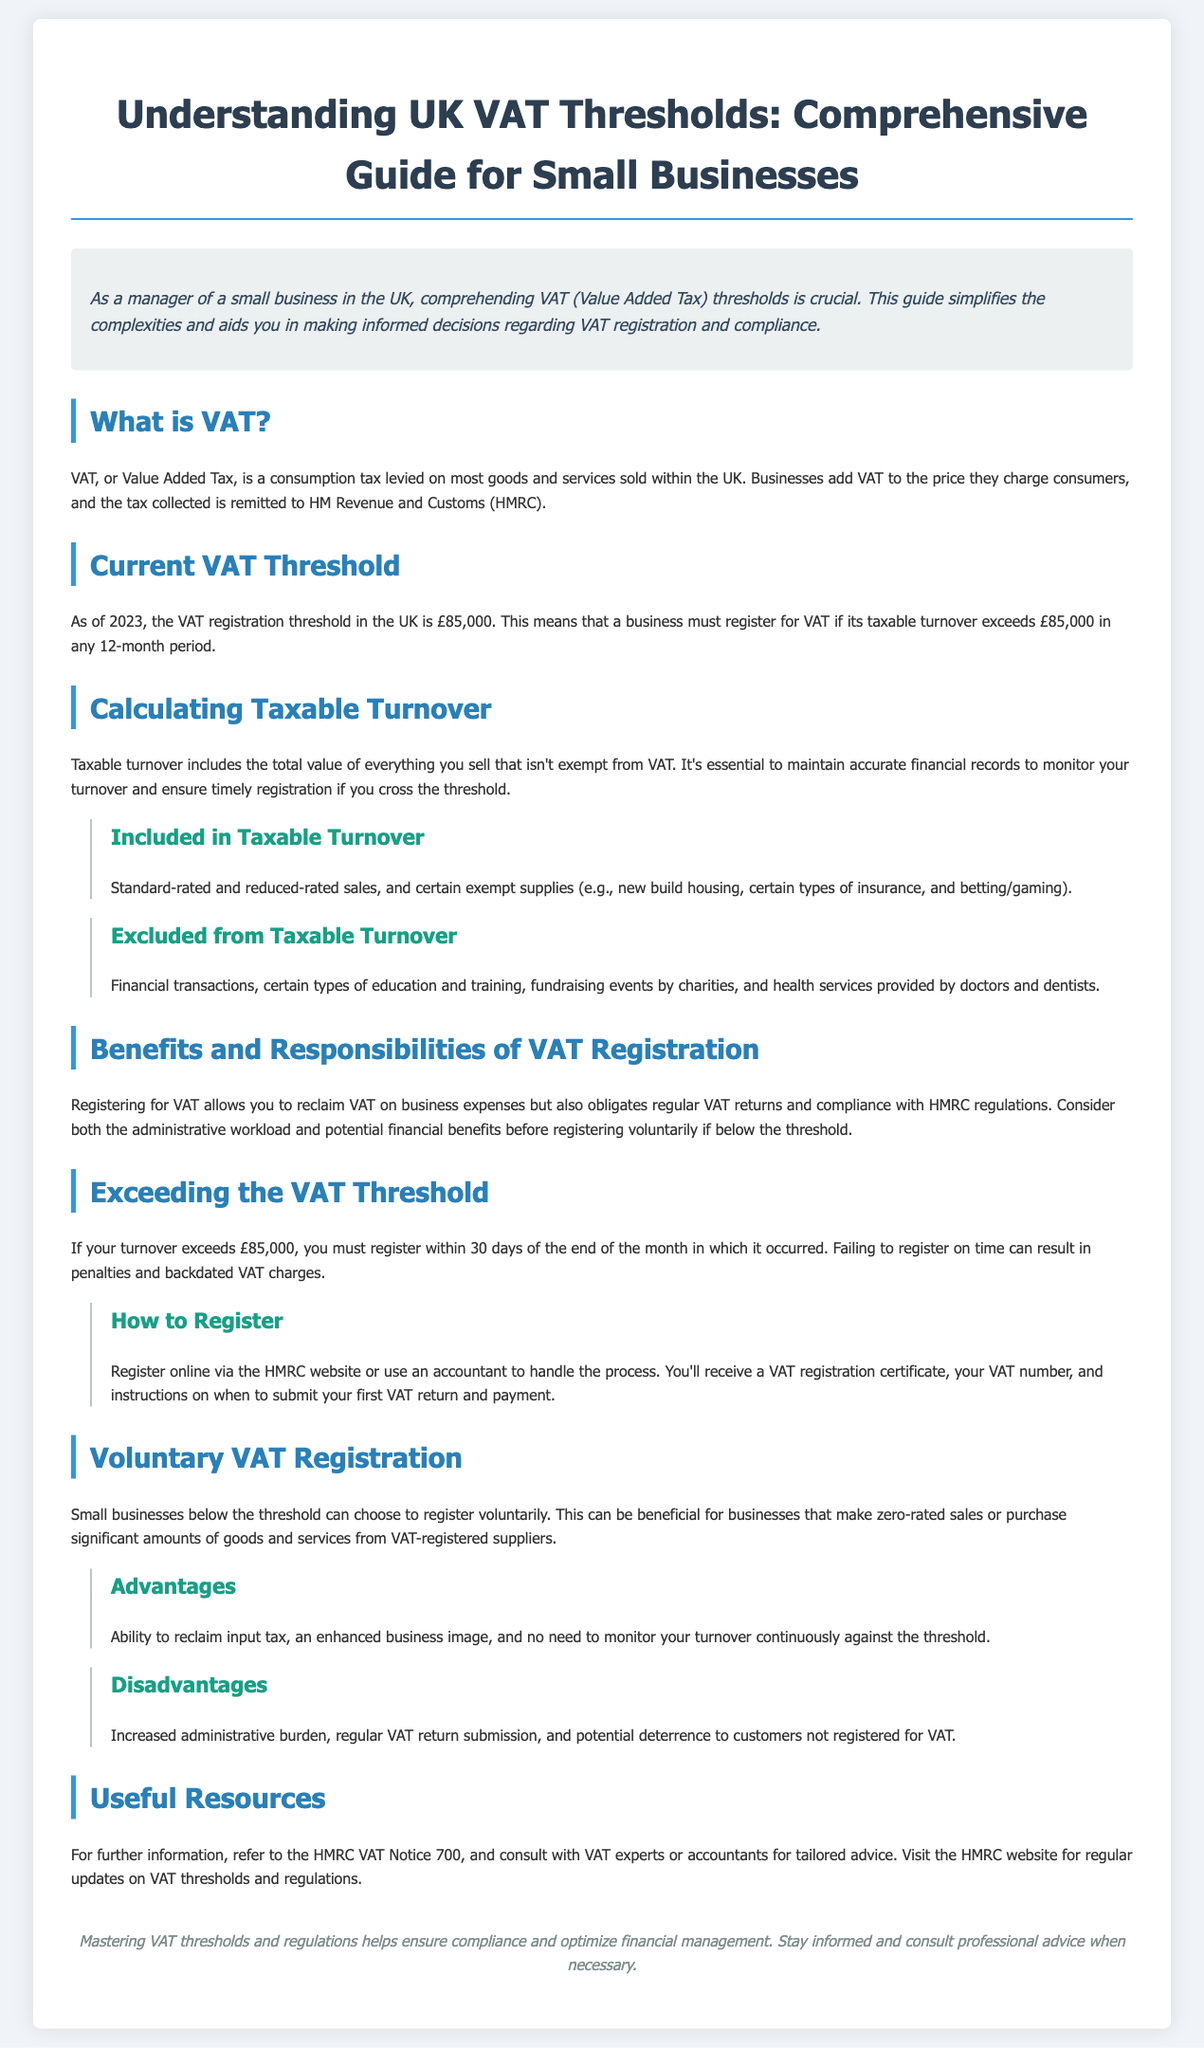What is VAT? VAT is defined as a consumption tax levied on most goods and services sold within the UK.
Answer: A consumption tax What is the VAT registration threshold in 2023? The document states that in 2023, the VAT registration threshold is £85,000.
Answer: £85,000 What must a business do if it exceeds the VAT threshold? The document indicates that a business must register within 30 days if turnover exceeds the threshold.
Answer: Register within 30 days What are businesses allowed to reclaim upon VAT registration? It is mentioned that businesses can reclaim VAT on business expenses once registered.
Answer: VAT on business expenses What is one disadvantage of voluntary VAT registration? The document lists an increased administrative burden as a disadvantage of voluntary registration.
Answer: Increased administrative burden Which transactions are excluded from taxable turnover? The information specifies that financial transactions are excluded from taxable turnover.
Answer: Financial transactions Name a benefit of voluntary VAT registration. The document states that one benefit is the ability to reclaim input tax.
Answer: Ability to reclaim input tax What document can provide further information on VAT? The document mentions HMRC VAT Notice 700 as a useful resource for further information.
Answer: HMRC VAT Notice 700 